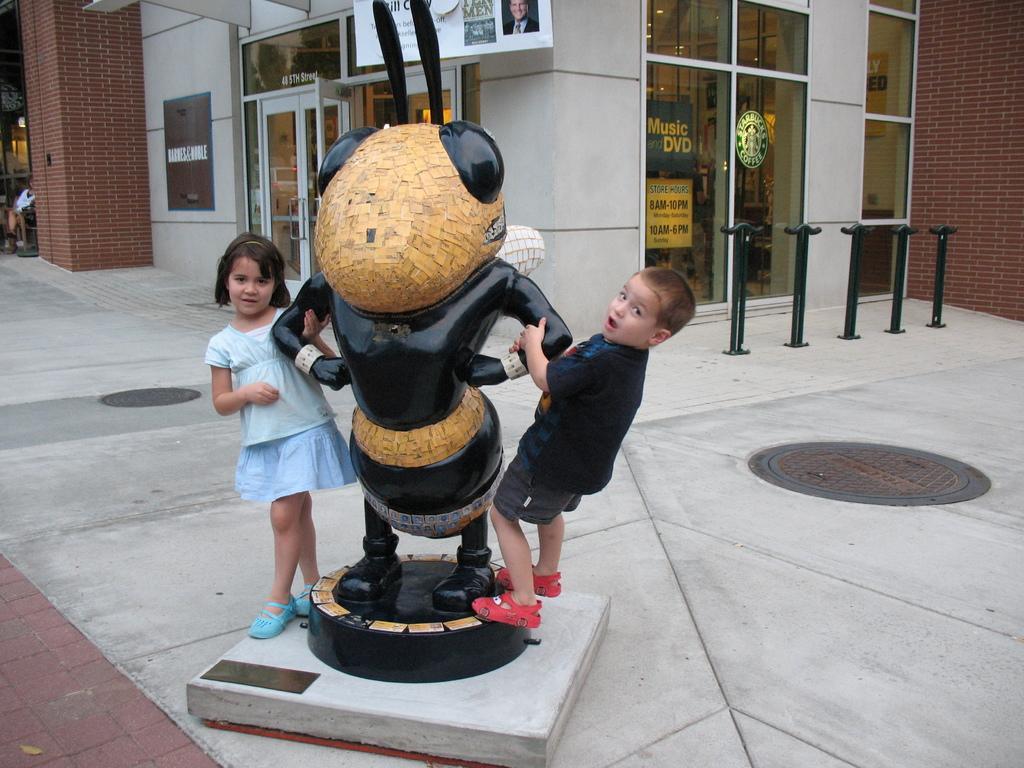Please provide a concise description of this image. In this image, in the middle, we can see a statue and two kids are holding a statue. In the background, we can see a glass window, brick wall, hoardings. At the bottom, we can see a land. 